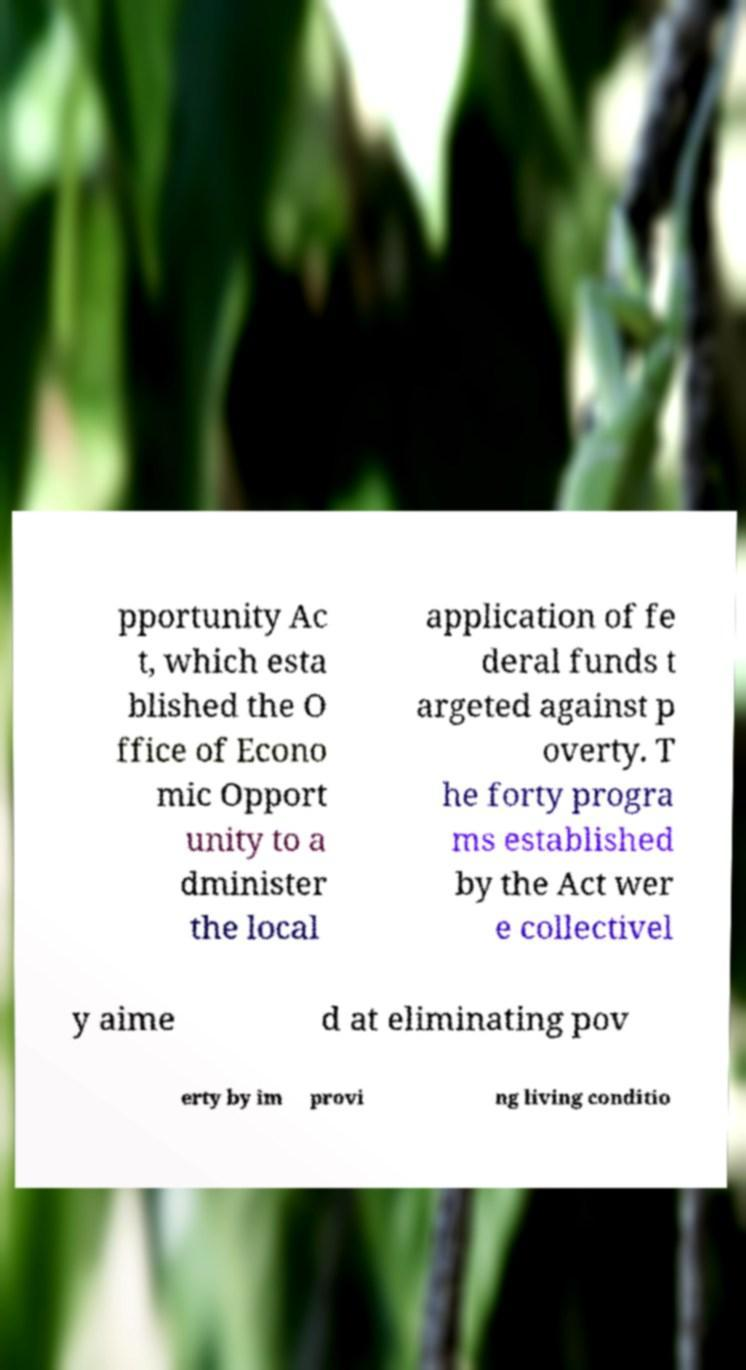Can you accurately transcribe the text from the provided image for me? pportunity Ac t, which esta blished the O ffice of Econo mic Opport unity to a dminister the local application of fe deral funds t argeted against p overty. T he forty progra ms established by the Act wer e collectivel y aime d at eliminating pov erty by im provi ng living conditio 